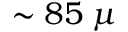Convert formula to latex. <formula><loc_0><loc_0><loc_500><loc_500>\sim 8 5 \, \mu</formula> 